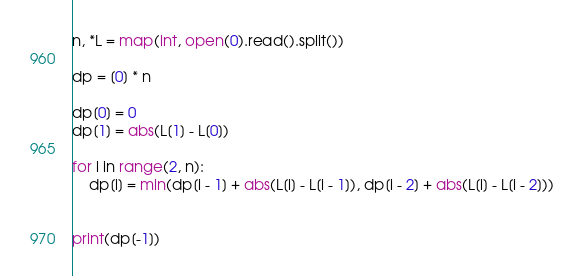<code> <loc_0><loc_0><loc_500><loc_500><_Python_>n, *L = map(int, open(0).read().split())

dp = [0] * n

dp[0] = 0
dp[1] = abs(L[1] - L[0])

for i in range(2, n):
    dp[i] = min(dp[i - 1] + abs(L[i] - L[i - 1]), dp[i - 2] + abs(L[i] - L[i - 2]))
    

print(dp[-1])
</code> 